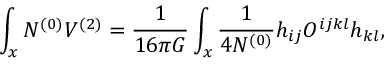<formula> <loc_0><loc_0><loc_500><loc_500>\int _ { x } N ^ { ( 0 ) } V ^ { ( 2 ) } = { \frac { 1 } { 1 6 \pi G } } \int _ { x } { \frac { 1 } { 4 N ^ { ( 0 ) } } } h _ { i j } O ^ { i j k l } h _ { k l } ,</formula> 